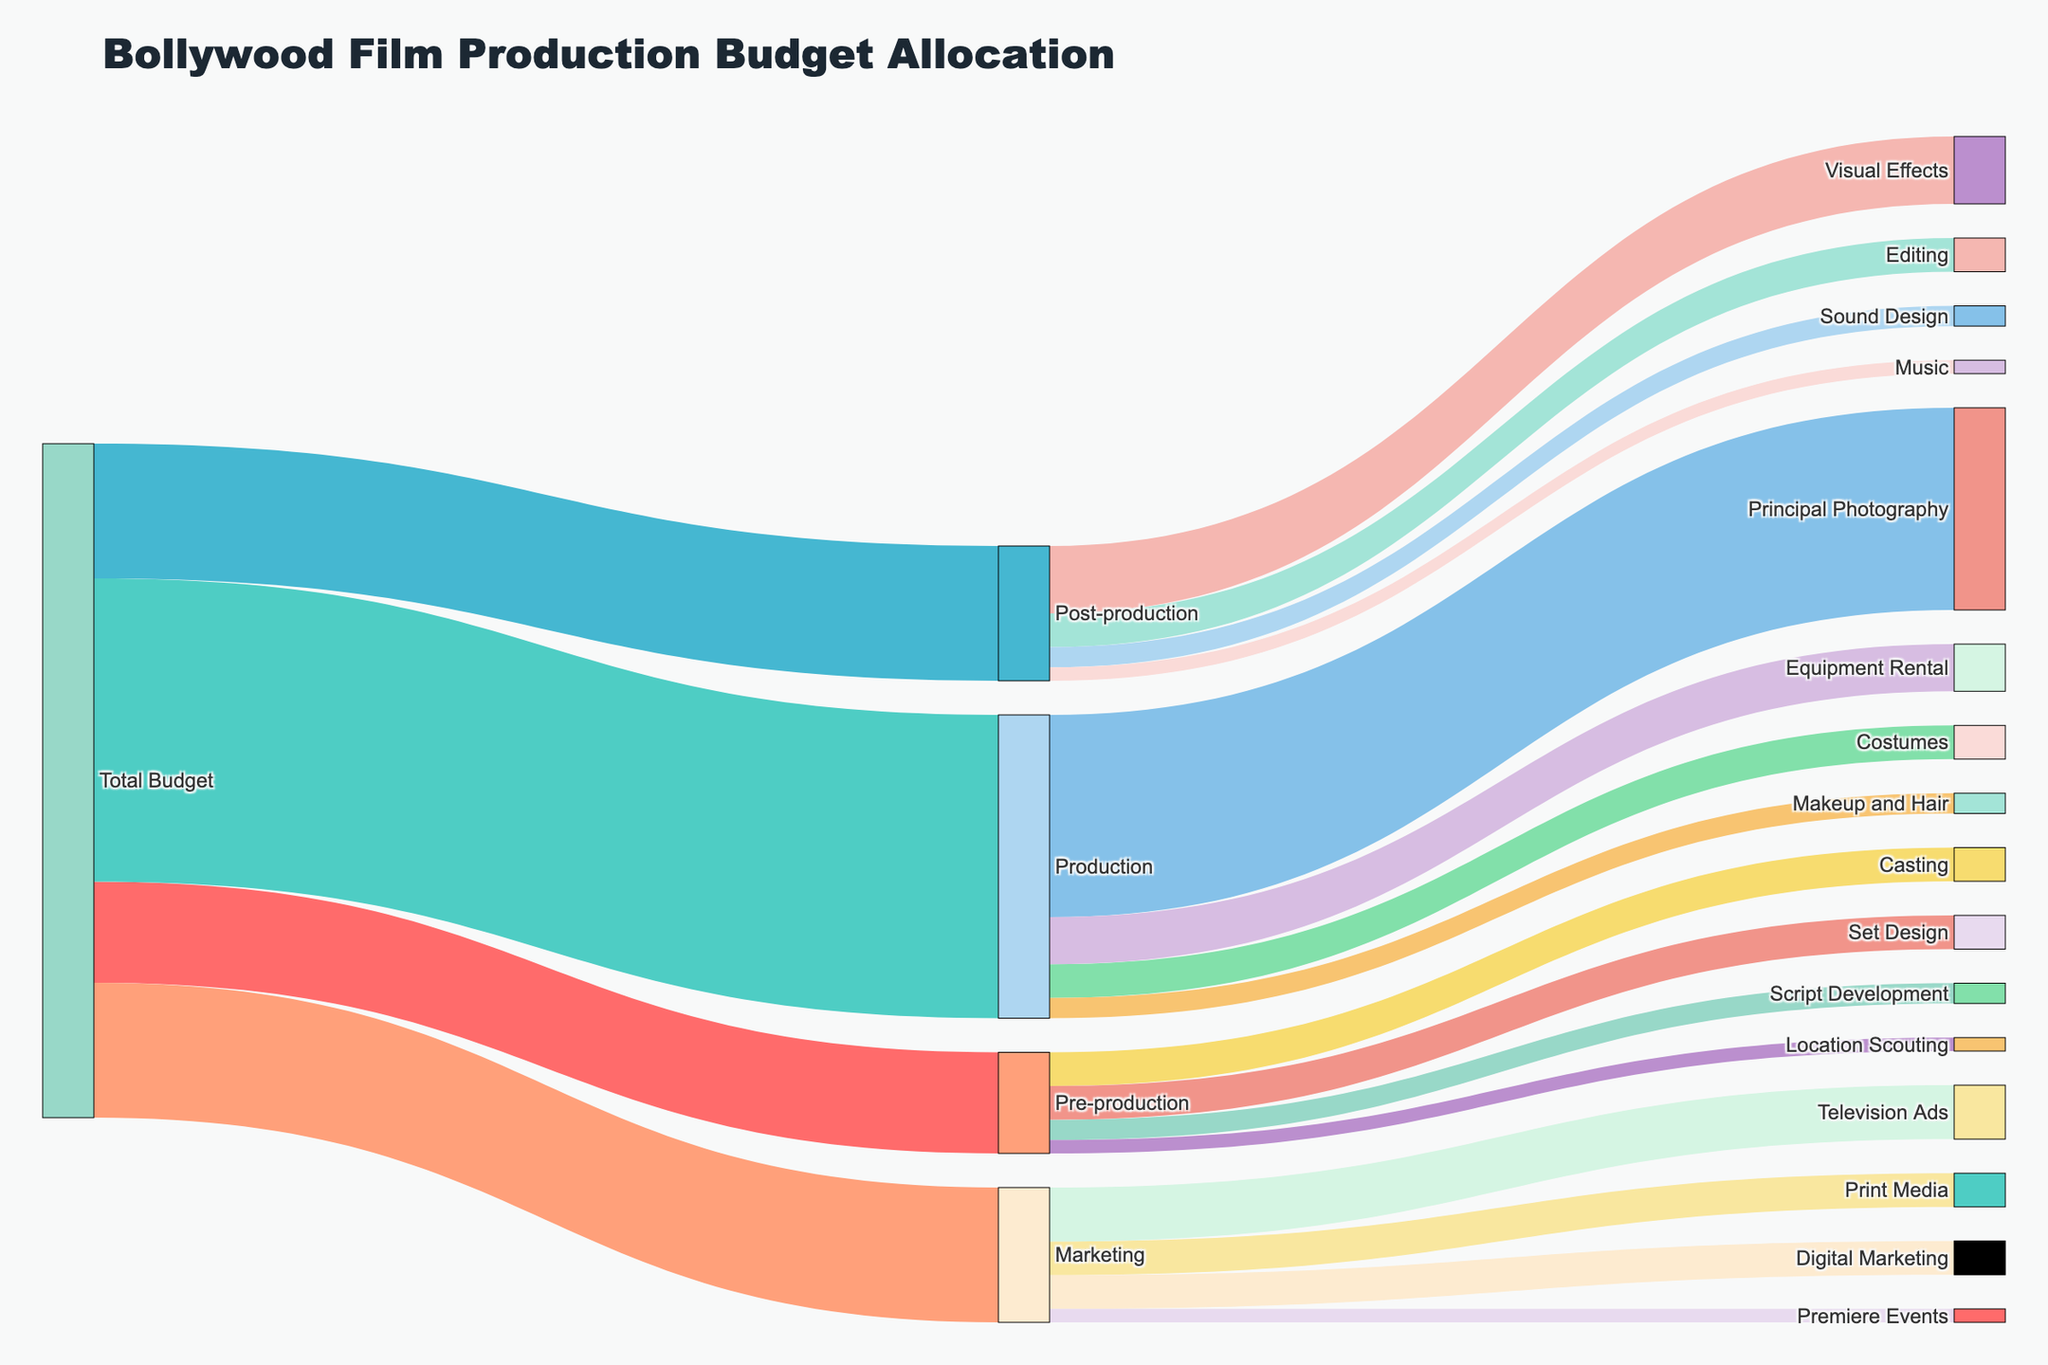What is the largest allocation under Total Budget? The largest allocation is found by comparing the values associated with the primary targets under Total Budget, namely Pre-production, Production, Post-production, and Marketing. Production has the highest value of 45,000,000.
Answer: Production What percentage of the Total Budget is allocated to Pre-production? The percentage is calculated as (value for Pre-production / Total value) * 100. So, (15,000,000 / 100,000,000) * 100 = 15%.
Answer: 15% Which expense category under Production has the smallest allocation? To find the smallest allocation under Production, compare the values for Principal Photography, Costumes, Makeup and Hair, and Equipment Rental. Makeup and Hair has the smallest allocation at 3,000,000.
Answer: Makeup and Hair What is the combined total allocated for Post-production and Marketing? Calculate the combined total by summing the values for Post-production and Marketing. Post-production has 20,000,000 and Marketing has 20,000,000. Therefore, the combined total is 20,000,000 + 20,000,000 = 40,000,000.
Answer: 40,000,000 Which step in Pre-production has the highest budget allocation? The highest budget allocation in Pre-production can be found by comparing the values for Script Development, Casting, Location Scouting, and Set Design. The highest allocation is for Casting at 5,000,000.
Answer: Casting How does the budget for Visual Effects in Post-production compare to the total Pre-production budget? Compare the budget for Visual Effects (10,000,000) with the total Pre-production budget (15,000,000). Visual Effects is less than the Pre-production budget.
Answer: Less If the budget for Television Ads in Marketing was reduced by 50%, what would the new total Marketing budget be? First, calculate 50% of Television Ads (0.5 * 8,000,000 = 4,000,000), then subtract that from the total Marketing budget (20,000,000 - 4,000,000 = 16,000,000).
Answer: 16,000,000 Out of Editing, Visual Effects, and Music in Post-production, which has the highest allocation? Compare the values for Editing (5,000,000), Visual Effects (10,000,000), and Music (2,000,000). Visual Effects has the highest allocation.
Answer: Visual Effects What proportion of the Production budget goes to Equipment Rental? The proportion is determined by dividing the Equipment Rental budget by the total Production budget. So, 7,000,000 / 45,000,000 = 0.1556 or approximately 15.56%.
Answer: 15.56% If 10% of the Total Budget was cut uniformly across all categories, how much would be cut from the Post-production budget? Calculate 10% of the Post-production budget. So, 0.10 * 20,000,000 = 2,000,000.
Answer: 2,000,000 